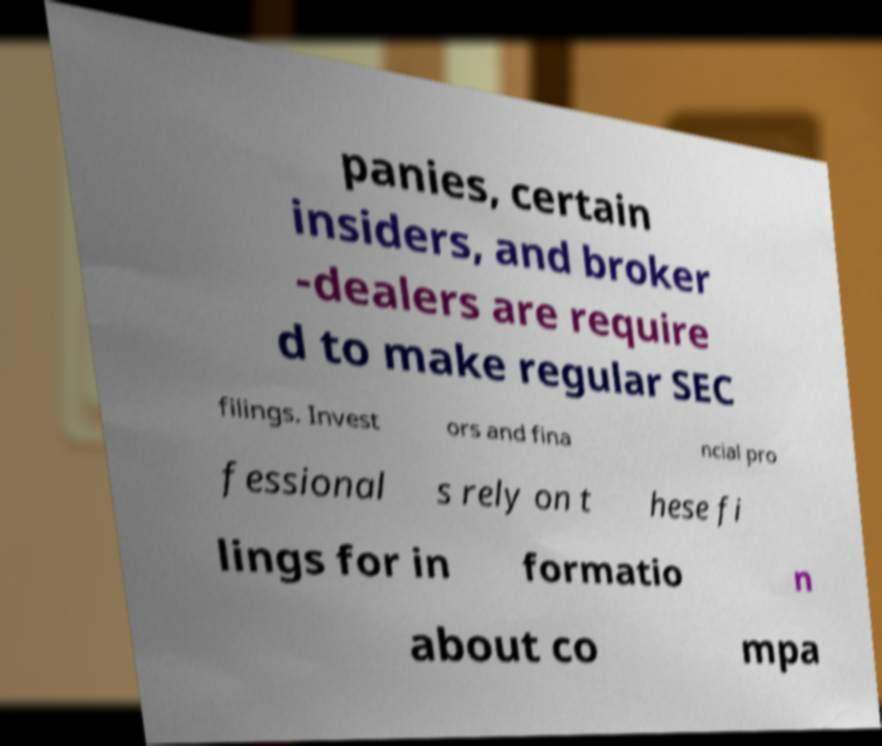There's text embedded in this image that I need extracted. Can you transcribe it verbatim? panies, certain insiders, and broker -dealers are require d to make regular SEC filings. Invest ors and fina ncial pro fessional s rely on t hese fi lings for in formatio n about co mpa 